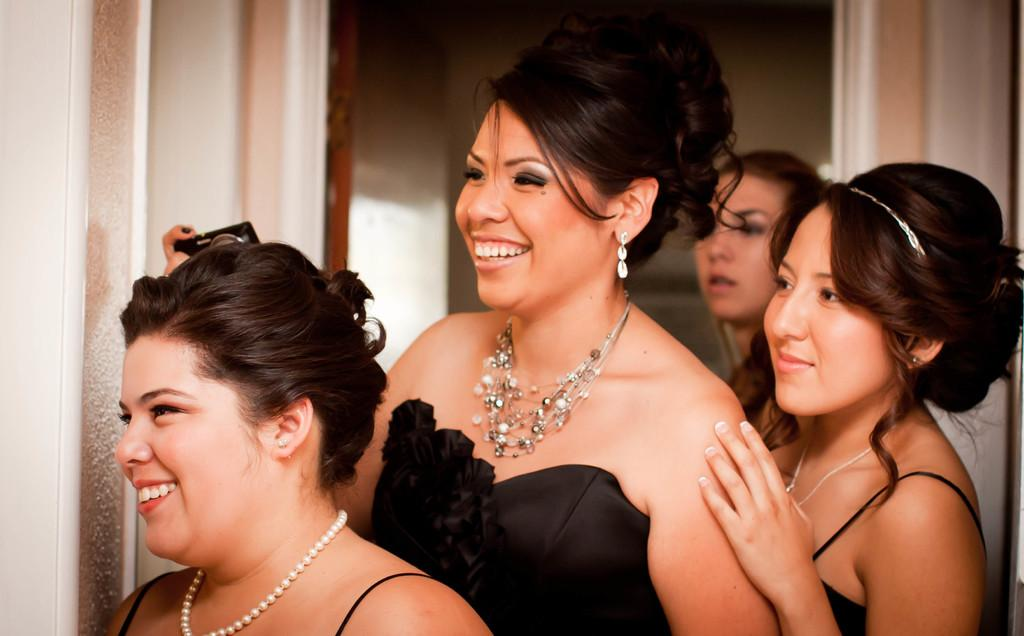What are the women in the image wearing? The women in the image are wearing black color dresses. What is the facial expression of the women in the image? The women are smiling in the image. Where are the women standing in the image? The women are standing near a white wall in the image. Can you describe the background of the image? There is another woman standing in the background of the image, and there is a white wall in the background as well. What type of growth can be observed in the image? There is no growth visible in the image; it features women standing near a white wall. What type of attraction is present in the image? There is no attraction depicted in the image; it simply shows women standing near a white wall. 